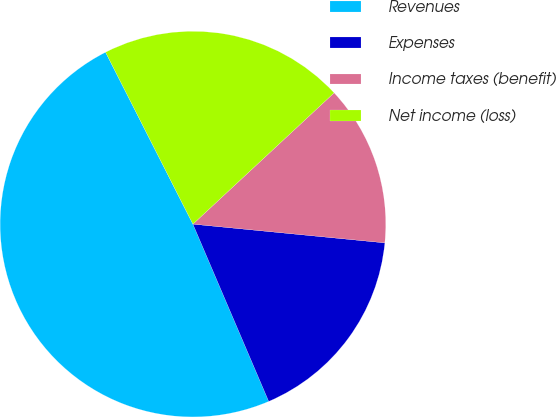Convert chart to OTSL. <chart><loc_0><loc_0><loc_500><loc_500><pie_chart><fcel>Revenues<fcel>Expenses<fcel>Income taxes (benefit)<fcel>Net income (loss)<nl><fcel>48.95%<fcel>17.02%<fcel>13.47%<fcel>20.56%<nl></chart> 